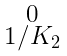<formula> <loc_0><loc_0><loc_500><loc_500>\begin{smallmatrix} 0 \\ 1 / K _ { 2 } \end{smallmatrix}</formula> 